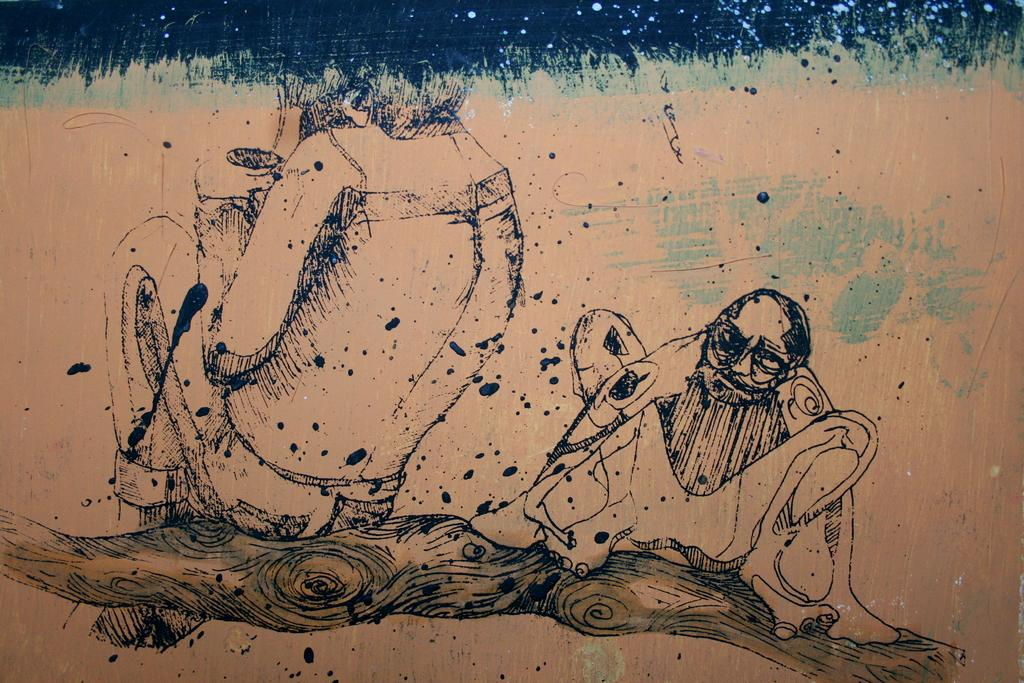What type of artwork is depicted in the image? The image is a painting. Where is the painting located? The painting is on a wall. How many dogs are visible in the painting? There are no dogs present in the image, as it is a painting and not a photograph. 